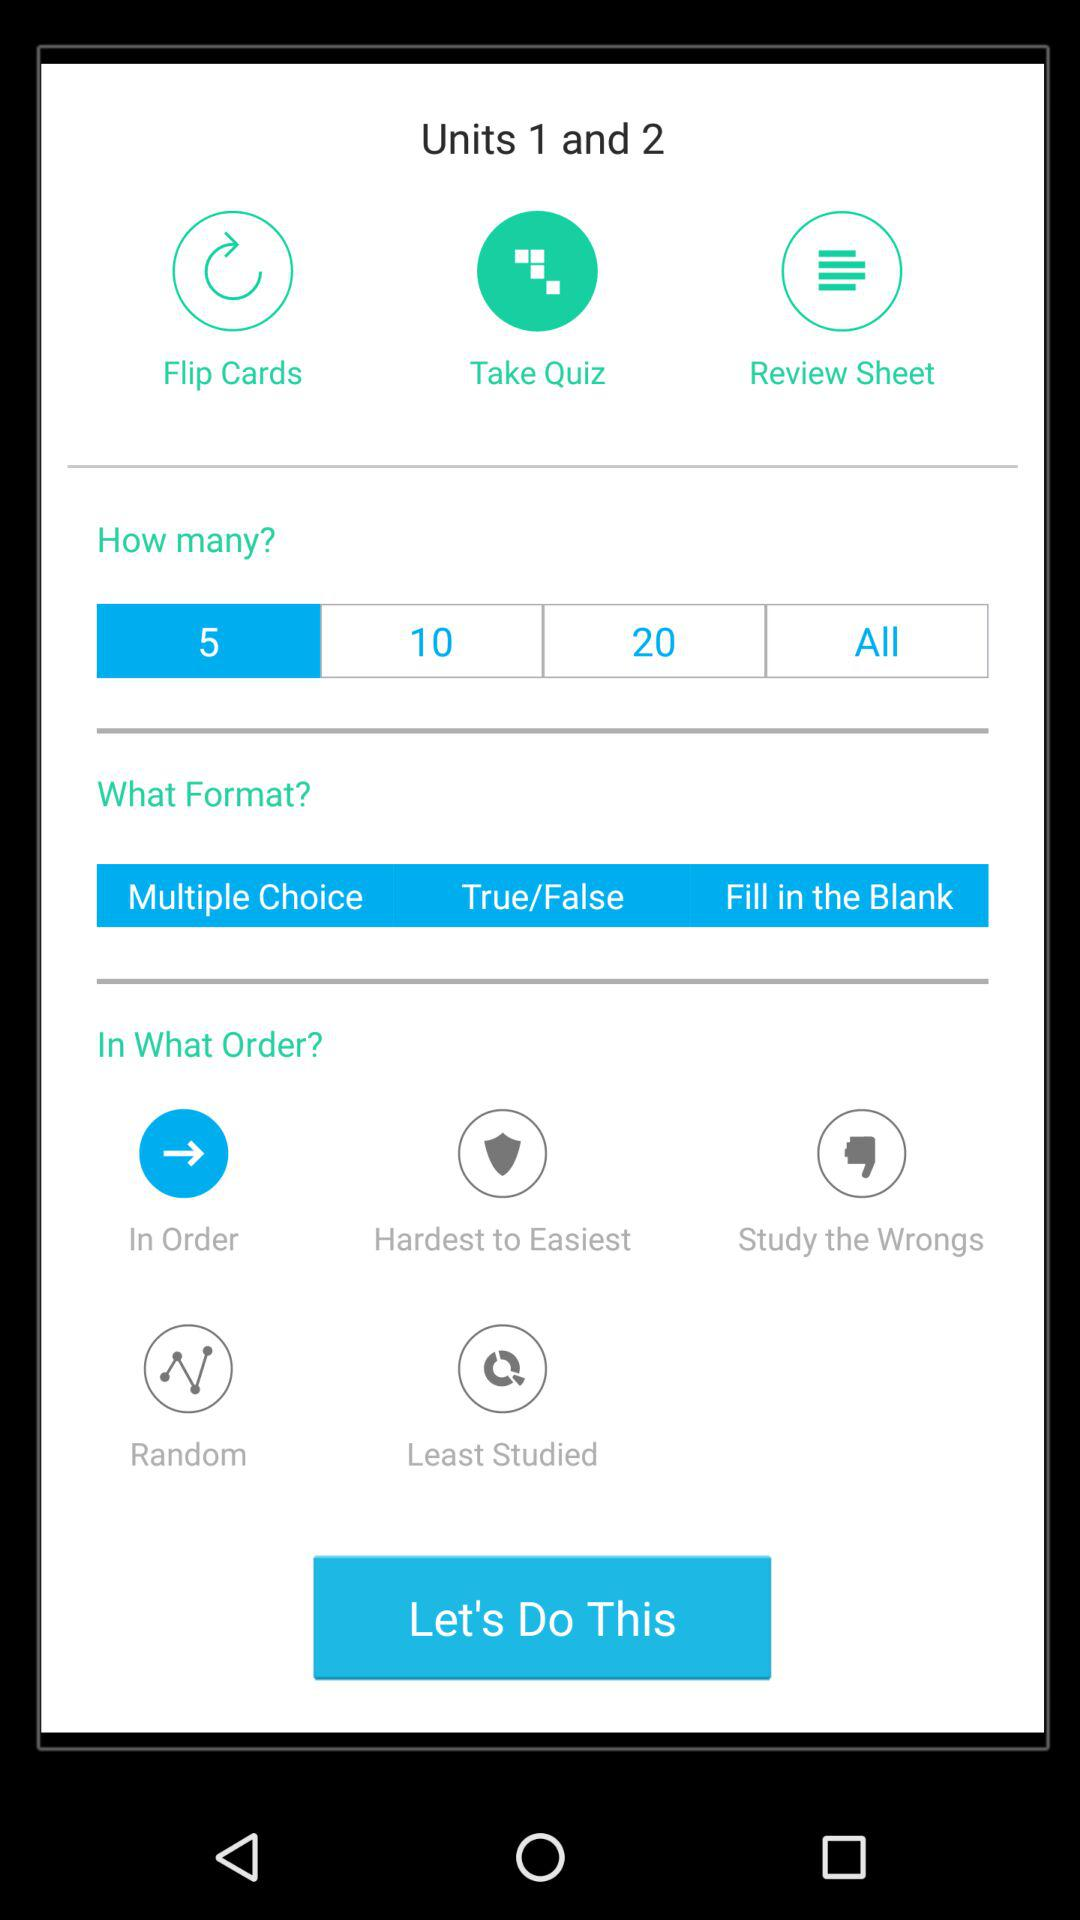How many different question types are available?
Answer the question using a single word or phrase. 3 